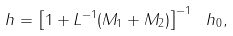Convert formula to latex. <formula><loc_0><loc_0><loc_500><loc_500>\ h = \left [ 1 + L ^ { - 1 } ( M _ { 1 } + M _ { 2 } ) \right ] ^ { - 1 } \ h _ { 0 } ,</formula> 